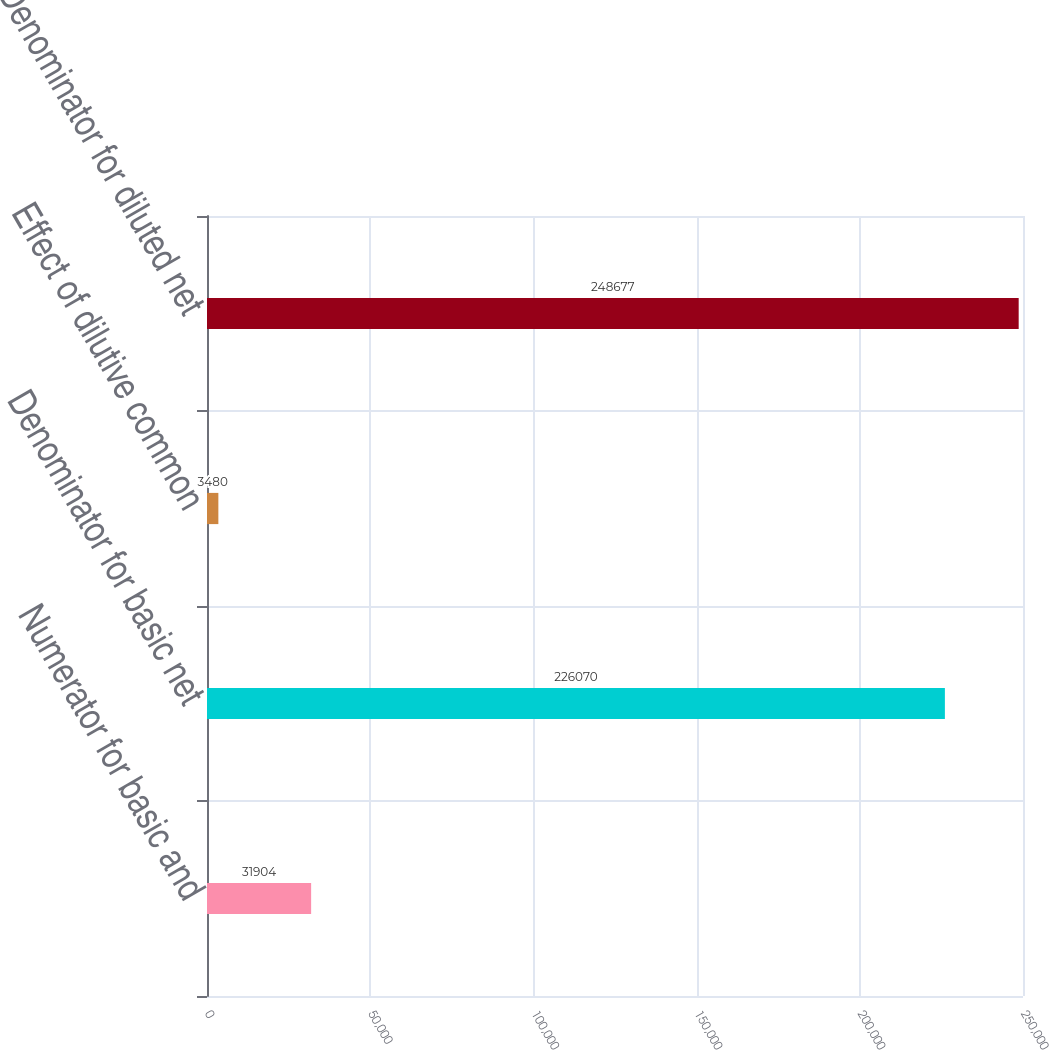Convert chart to OTSL. <chart><loc_0><loc_0><loc_500><loc_500><bar_chart><fcel>Numerator for basic and<fcel>Denominator for basic net<fcel>Effect of dilutive common<fcel>Denominator for diluted net<nl><fcel>31904<fcel>226070<fcel>3480<fcel>248677<nl></chart> 